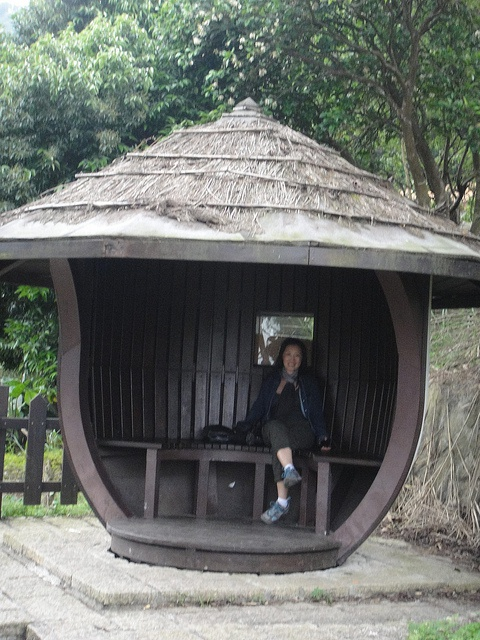Describe the objects in this image and their specific colors. I can see people in white, black, gray, and darkgray tones, bench in white, black, and gray tones, and handbag in white, black, and gray tones in this image. 